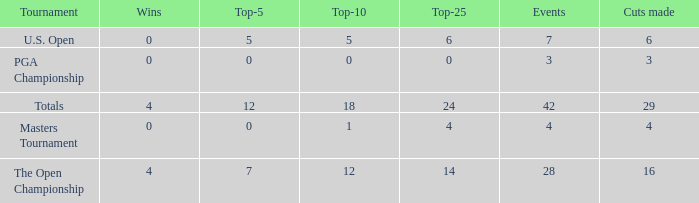What is the event average for a top-25 smaller than 0? None. 